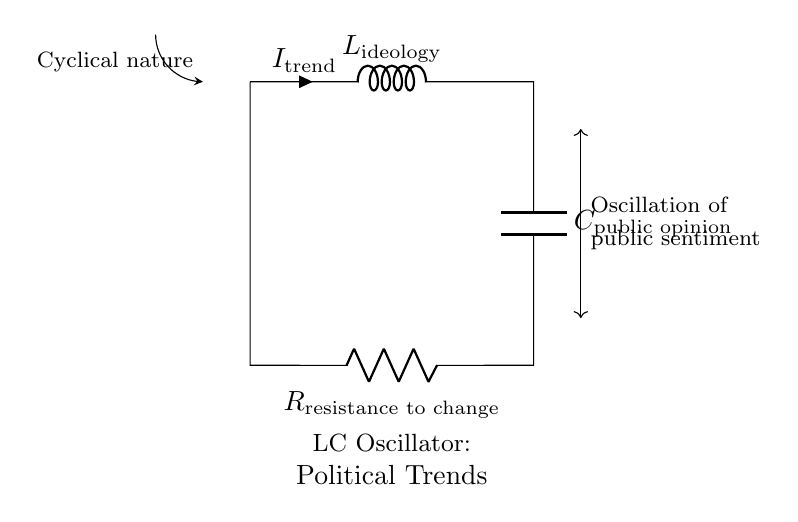What are the components in this circuit? The components are an inductor labeled L_ideology, a capacitor labeled C_public opinion, and a resistor labeled R_resistance to change. These components are fundamental to the oscillating behavior of the circuit.
Answer: L_ideology, C_public opinion, R_resistance to change What does the current label indicate in the circuit? The current label I_trend indicates the direction and magnitude of the current flowing through the inductor, which relates to the overall trends in political ideologies over time.
Answer: I_trend What does the forgoing arc symbolize? The arc symbolizes the cyclical nature of political trends and fluctuations in public sentiment, indicating that opinions oscillate rather than remain constant.
Answer: Cyclical nature How does resistance affect oscillation in this circuit? Resistance introduces damping in the oscillation, meaning that higher resistance would reduce the amplitude and frequency of oscillations, simulating a resistance to change in public opinion.
Answer: Damping Which component best represents the concept of public sentiment? The capacitor C_public opinion stores energy in the form of electric charge and is analogous to public sentiment that builds up and fluctuates over time based on ideological currents.
Answer: C_public opinion What type of circuit is depicted in this diagram? The diagram depicts an LC oscillator circuit, which is characterized by its use of inductors and capacitors to create oscillating signals, analogous to the dynamics of political trends.
Answer: LC oscillator 